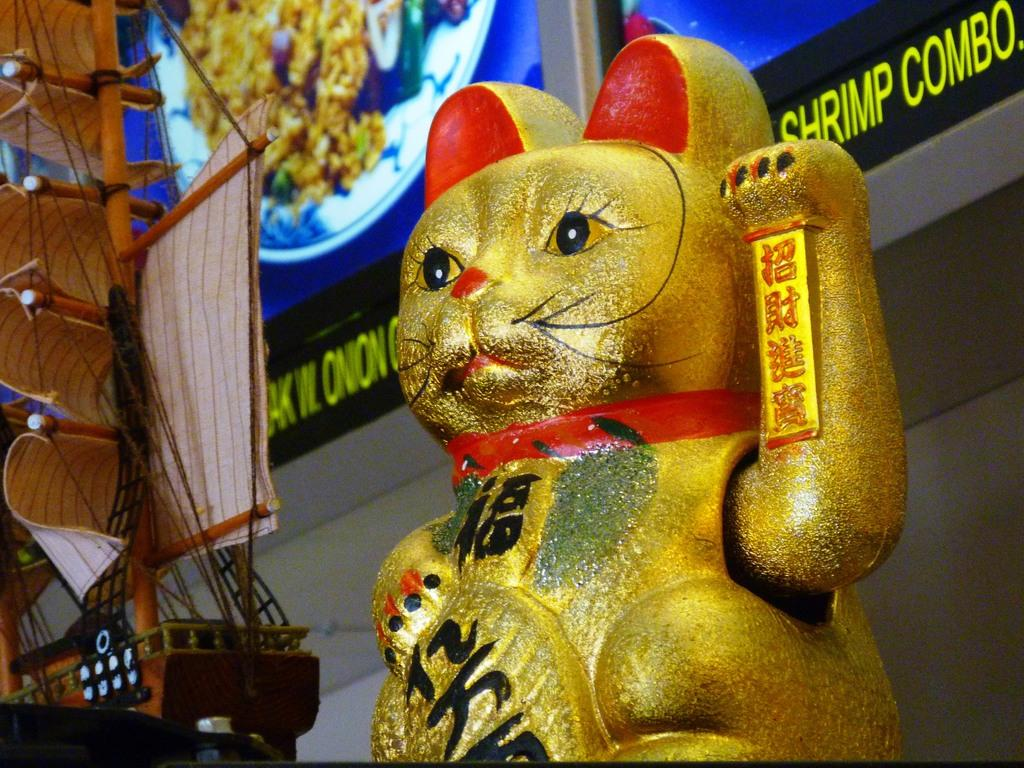What type of toy can be seen in the image? There is a toy that looks like a cat in the image. What color is the toy cat? The toy cat is gold in color. What else is present in the image besides the toy cat? There is a ship in the image. What can be seen on the walls in the background of the image? There are photo frames attached to the walls in the background of the image. What type of substance is being used to power the ship in the image? There is no indication of the ship's power source in the image, and therefore no such substance can be identified. 